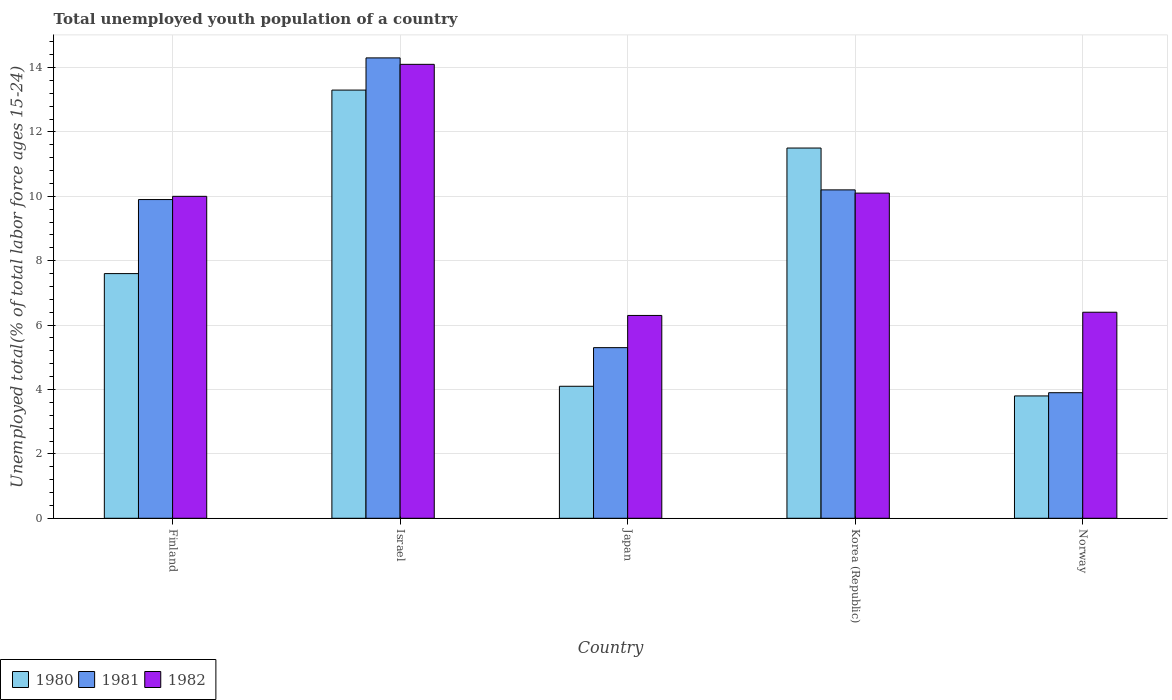How many different coloured bars are there?
Your answer should be compact. 3. How many groups of bars are there?
Keep it short and to the point. 5. How many bars are there on the 2nd tick from the left?
Your response must be concise. 3. How many bars are there on the 5th tick from the right?
Keep it short and to the point. 3. What is the label of the 2nd group of bars from the left?
Keep it short and to the point. Israel. What is the percentage of total unemployed youth population of a country in 1981 in Finland?
Ensure brevity in your answer.  9.9. Across all countries, what is the maximum percentage of total unemployed youth population of a country in 1981?
Ensure brevity in your answer.  14.3. Across all countries, what is the minimum percentage of total unemployed youth population of a country in 1980?
Offer a terse response. 3.8. What is the total percentage of total unemployed youth population of a country in 1982 in the graph?
Provide a short and direct response. 46.9. What is the difference between the percentage of total unemployed youth population of a country in 1980 in Israel and that in Korea (Republic)?
Your answer should be very brief. 1.8. What is the difference between the percentage of total unemployed youth population of a country in 1982 in Israel and the percentage of total unemployed youth population of a country in 1981 in Japan?
Offer a terse response. 8.8. What is the average percentage of total unemployed youth population of a country in 1982 per country?
Make the answer very short. 9.38. What is the difference between the percentage of total unemployed youth population of a country of/in 1980 and percentage of total unemployed youth population of a country of/in 1982 in Finland?
Offer a terse response. -2.4. In how many countries, is the percentage of total unemployed youth population of a country in 1981 greater than 1.6 %?
Your answer should be compact. 5. What is the ratio of the percentage of total unemployed youth population of a country in 1981 in Israel to that in Japan?
Give a very brief answer. 2.7. Is the percentage of total unemployed youth population of a country in 1981 in Israel less than that in Korea (Republic)?
Offer a terse response. No. Is the difference between the percentage of total unemployed youth population of a country in 1980 in Finland and Korea (Republic) greater than the difference between the percentage of total unemployed youth population of a country in 1982 in Finland and Korea (Republic)?
Make the answer very short. No. What is the difference between the highest and the second highest percentage of total unemployed youth population of a country in 1980?
Give a very brief answer. -1.8. What is the difference between the highest and the lowest percentage of total unemployed youth population of a country in 1981?
Offer a very short reply. 10.4. What does the 1st bar from the right in Japan represents?
Your answer should be compact. 1982. Is it the case that in every country, the sum of the percentage of total unemployed youth population of a country in 1980 and percentage of total unemployed youth population of a country in 1981 is greater than the percentage of total unemployed youth population of a country in 1982?
Give a very brief answer. Yes. How many bars are there?
Give a very brief answer. 15. Are all the bars in the graph horizontal?
Ensure brevity in your answer.  No. Are the values on the major ticks of Y-axis written in scientific E-notation?
Ensure brevity in your answer.  No. Does the graph contain grids?
Your response must be concise. Yes. Where does the legend appear in the graph?
Your answer should be compact. Bottom left. How are the legend labels stacked?
Your response must be concise. Horizontal. What is the title of the graph?
Make the answer very short. Total unemployed youth population of a country. What is the label or title of the Y-axis?
Ensure brevity in your answer.  Unemployed total(% of total labor force ages 15-24). What is the Unemployed total(% of total labor force ages 15-24) of 1980 in Finland?
Offer a terse response. 7.6. What is the Unemployed total(% of total labor force ages 15-24) in 1981 in Finland?
Your answer should be compact. 9.9. What is the Unemployed total(% of total labor force ages 15-24) in 1982 in Finland?
Provide a short and direct response. 10. What is the Unemployed total(% of total labor force ages 15-24) of 1980 in Israel?
Make the answer very short. 13.3. What is the Unemployed total(% of total labor force ages 15-24) of 1981 in Israel?
Ensure brevity in your answer.  14.3. What is the Unemployed total(% of total labor force ages 15-24) in 1982 in Israel?
Keep it short and to the point. 14.1. What is the Unemployed total(% of total labor force ages 15-24) of 1980 in Japan?
Keep it short and to the point. 4.1. What is the Unemployed total(% of total labor force ages 15-24) in 1981 in Japan?
Provide a short and direct response. 5.3. What is the Unemployed total(% of total labor force ages 15-24) of 1982 in Japan?
Ensure brevity in your answer.  6.3. What is the Unemployed total(% of total labor force ages 15-24) in 1980 in Korea (Republic)?
Ensure brevity in your answer.  11.5. What is the Unemployed total(% of total labor force ages 15-24) of 1981 in Korea (Republic)?
Offer a very short reply. 10.2. What is the Unemployed total(% of total labor force ages 15-24) of 1982 in Korea (Republic)?
Give a very brief answer. 10.1. What is the Unemployed total(% of total labor force ages 15-24) in 1980 in Norway?
Your answer should be compact. 3.8. What is the Unemployed total(% of total labor force ages 15-24) in 1981 in Norway?
Give a very brief answer. 3.9. What is the Unemployed total(% of total labor force ages 15-24) in 1982 in Norway?
Give a very brief answer. 6.4. Across all countries, what is the maximum Unemployed total(% of total labor force ages 15-24) of 1980?
Your answer should be compact. 13.3. Across all countries, what is the maximum Unemployed total(% of total labor force ages 15-24) in 1981?
Provide a short and direct response. 14.3. Across all countries, what is the maximum Unemployed total(% of total labor force ages 15-24) in 1982?
Provide a succinct answer. 14.1. Across all countries, what is the minimum Unemployed total(% of total labor force ages 15-24) of 1980?
Your answer should be very brief. 3.8. Across all countries, what is the minimum Unemployed total(% of total labor force ages 15-24) of 1981?
Keep it short and to the point. 3.9. Across all countries, what is the minimum Unemployed total(% of total labor force ages 15-24) of 1982?
Your answer should be compact. 6.3. What is the total Unemployed total(% of total labor force ages 15-24) of 1980 in the graph?
Give a very brief answer. 40.3. What is the total Unemployed total(% of total labor force ages 15-24) of 1981 in the graph?
Provide a short and direct response. 43.6. What is the total Unemployed total(% of total labor force ages 15-24) of 1982 in the graph?
Provide a succinct answer. 46.9. What is the difference between the Unemployed total(% of total labor force ages 15-24) in 1980 in Finland and that in Israel?
Ensure brevity in your answer.  -5.7. What is the difference between the Unemployed total(% of total labor force ages 15-24) in 1982 in Finland and that in Norway?
Your answer should be compact. 3.6. What is the difference between the Unemployed total(% of total labor force ages 15-24) in 1981 in Israel and that in Japan?
Your answer should be very brief. 9. What is the difference between the Unemployed total(% of total labor force ages 15-24) in 1982 in Israel and that in Japan?
Provide a short and direct response. 7.8. What is the difference between the Unemployed total(% of total labor force ages 15-24) in 1980 in Israel and that in Korea (Republic)?
Make the answer very short. 1.8. What is the difference between the Unemployed total(% of total labor force ages 15-24) in 1982 in Israel and that in Korea (Republic)?
Your response must be concise. 4. What is the difference between the Unemployed total(% of total labor force ages 15-24) in 1980 in Israel and that in Norway?
Ensure brevity in your answer.  9.5. What is the difference between the Unemployed total(% of total labor force ages 15-24) in 1981 in Israel and that in Norway?
Offer a terse response. 10.4. What is the difference between the Unemployed total(% of total labor force ages 15-24) in 1982 in Israel and that in Norway?
Your response must be concise. 7.7. What is the difference between the Unemployed total(% of total labor force ages 15-24) in 1980 in Japan and that in Korea (Republic)?
Provide a succinct answer. -7.4. What is the difference between the Unemployed total(% of total labor force ages 15-24) of 1981 in Japan and that in Korea (Republic)?
Your response must be concise. -4.9. What is the difference between the Unemployed total(% of total labor force ages 15-24) in 1982 in Japan and that in Korea (Republic)?
Your answer should be compact. -3.8. What is the difference between the Unemployed total(% of total labor force ages 15-24) in 1982 in Japan and that in Norway?
Make the answer very short. -0.1. What is the difference between the Unemployed total(% of total labor force ages 15-24) of 1980 in Korea (Republic) and that in Norway?
Your answer should be very brief. 7.7. What is the difference between the Unemployed total(% of total labor force ages 15-24) of 1980 in Finland and the Unemployed total(% of total labor force ages 15-24) of 1981 in Israel?
Your response must be concise. -6.7. What is the difference between the Unemployed total(% of total labor force ages 15-24) in 1981 in Finland and the Unemployed total(% of total labor force ages 15-24) in 1982 in Israel?
Offer a very short reply. -4.2. What is the difference between the Unemployed total(% of total labor force ages 15-24) in 1980 in Finland and the Unemployed total(% of total labor force ages 15-24) in 1982 in Japan?
Ensure brevity in your answer.  1.3. What is the difference between the Unemployed total(% of total labor force ages 15-24) in 1980 in Finland and the Unemployed total(% of total labor force ages 15-24) in 1981 in Korea (Republic)?
Give a very brief answer. -2.6. What is the difference between the Unemployed total(% of total labor force ages 15-24) in 1981 in Finland and the Unemployed total(% of total labor force ages 15-24) in 1982 in Norway?
Ensure brevity in your answer.  3.5. What is the difference between the Unemployed total(% of total labor force ages 15-24) in 1980 in Israel and the Unemployed total(% of total labor force ages 15-24) in 1981 in Japan?
Ensure brevity in your answer.  8. What is the difference between the Unemployed total(% of total labor force ages 15-24) of 1980 in Israel and the Unemployed total(% of total labor force ages 15-24) of 1982 in Japan?
Make the answer very short. 7. What is the difference between the Unemployed total(% of total labor force ages 15-24) of 1981 in Israel and the Unemployed total(% of total labor force ages 15-24) of 1982 in Japan?
Ensure brevity in your answer.  8. What is the difference between the Unemployed total(% of total labor force ages 15-24) of 1980 in Israel and the Unemployed total(% of total labor force ages 15-24) of 1981 in Korea (Republic)?
Offer a very short reply. 3.1. What is the difference between the Unemployed total(% of total labor force ages 15-24) of 1980 in Israel and the Unemployed total(% of total labor force ages 15-24) of 1982 in Korea (Republic)?
Offer a terse response. 3.2. What is the difference between the Unemployed total(% of total labor force ages 15-24) in 1981 in Israel and the Unemployed total(% of total labor force ages 15-24) in 1982 in Korea (Republic)?
Your response must be concise. 4.2. What is the difference between the Unemployed total(% of total labor force ages 15-24) in 1981 in Israel and the Unemployed total(% of total labor force ages 15-24) in 1982 in Norway?
Your response must be concise. 7.9. What is the difference between the Unemployed total(% of total labor force ages 15-24) in 1981 in Japan and the Unemployed total(% of total labor force ages 15-24) in 1982 in Korea (Republic)?
Your answer should be compact. -4.8. What is the difference between the Unemployed total(% of total labor force ages 15-24) in 1980 in Japan and the Unemployed total(% of total labor force ages 15-24) in 1982 in Norway?
Provide a succinct answer. -2.3. What is the difference between the Unemployed total(% of total labor force ages 15-24) in 1980 in Korea (Republic) and the Unemployed total(% of total labor force ages 15-24) in 1981 in Norway?
Provide a succinct answer. 7.6. What is the difference between the Unemployed total(% of total labor force ages 15-24) in 1980 in Korea (Republic) and the Unemployed total(% of total labor force ages 15-24) in 1982 in Norway?
Your answer should be very brief. 5.1. What is the average Unemployed total(% of total labor force ages 15-24) in 1980 per country?
Offer a terse response. 8.06. What is the average Unemployed total(% of total labor force ages 15-24) of 1981 per country?
Give a very brief answer. 8.72. What is the average Unemployed total(% of total labor force ages 15-24) of 1982 per country?
Keep it short and to the point. 9.38. What is the difference between the Unemployed total(% of total labor force ages 15-24) of 1980 and Unemployed total(% of total labor force ages 15-24) of 1982 in Finland?
Your answer should be very brief. -2.4. What is the difference between the Unemployed total(% of total labor force ages 15-24) of 1981 and Unemployed total(% of total labor force ages 15-24) of 1982 in Finland?
Ensure brevity in your answer.  -0.1. What is the difference between the Unemployed total(% of total labor force ages 15-24) in 1980 and Unemployed total(% of total labor force ages 15-24) in 1981 in Israel?
Give a very brief answer. -1. What is the difference between the Unemployed total(% of total labor force ages 15-24) of 1980 and Unemployed total(% of total labor force ages 15-24) of 1982 in Israel?
Make the answer very short. -0.8. What is the difference between the Unemployed total(% of total labor force ages 15-24) of 1981 and Unemployed total(% of total labor force ages 15-24) of 1982 in Israel?
Keep it short and to the point. 0.2. What is the difference between the Unemployed total(% of total labor force ages 15-24) in 1980 and Unemployed total(% of total labor force ages 15-24) in 1981 in Japan?
Offer a very short reply. -1.2. What is the difference between the Unemployed total(% of total labor force ages 15-24) of 1981 and Unemployed total(% of total labor force ages 15-24) of 1982 in Japan?
Give a very brief answer. -1. What is the difference between the Unemployed total(% of total labor force ages 15-24) of 1981 and Unemployed total(% of total labor force ages 15-24) of 1982 in Korea (Republic)?
Offer a very short reply. 0.1. What is the difference between the Unemployed total(% of total labor force ages 15-24) of 1981 and Unemployed total(% of total labor force ages 15-24) of 1982 in Norway?
Make the answer very short. -2.5. What is the ratio of the Unemployed total(% of total labor force ages 15-24) in 1980 in Finland to that in Israel?
Offer a very short reply. 0.57. What is the ratio of the Unemployed total(% of total labor force ages 15-24) in 1981 in Finland to that in Israel?
Ensure brevity in your answer.  0.69. What is the ratio of the Unemployed total(% of total labor force ages 15-24) of 1982 in Finland to that in Israel?
Offer a very short reply. 0.71. What is the ratio of the Unemployed total(% of total labor force ages 15-24) of 1980 in Finland to that in Japan?
Keep it short and to the point. 1.85. What is the ratio of the Unemployed total(% of total labor force ages 15-24) in 1981 in Finland to that in Japan?
Provide a succinct answer. 1.87. What is the ratio of the Unemployed total(% of total labor force ages 15-24) of 1982 in Finland to that in Japan?
Your response must be concise. 1.59. What is the ratio of the Unemployed total(% of total labor force ages 15-24) of 1980 in Finland to that in Korea (Republic)?
Provide a short and direct response. 0.66. What is the ratio of the Unemployed total(% of total labor force ages 15-24) in 1981 in Finland to that in Korea (Republic)?
Provide a succinct answer. 0.97. What is the ratio of the Unemployed total(% of total labor force ages 15-24) of 1982 in Finland to that in Korea (Republic)?
Provide a short and direct response. 0.99. What is the ratio of the Unemployed total(% of total labor force ages 15-24) of 1980 in Finland to that in Norway?
Ensure brevity in your answer.  2. What is the ratio of the Unemployed total(% of total labor force ages 15-24) in 1981 in Finland to that in Norway?
Keep it short and to the point. 2.54. What is the ratio of the Unemployed total(% of total labor force ages 15-24) in 1982 in Finland to that in Norway?
Provide a succinct answer. 1.56. What is the ratio of the Unemployed total(% of total labor force ages 15-24) of 1980 in Israel to that in Japan?
Offer a very short reply. 3.24. What is the ratio of the Unemployed total(% of total labor force ages 15-24) of 1981 in Israel to that in Japan?
Offer a very short reply. 2.7. What is the ratio of the Unemployed total(% of total labor force ages 15-24) of 1982 in Israel to that in Japan?
Keep it short and to the point. 2.24. What is the ratio of the Unemployed total(% of total labor force ages 15-24) of 1980 in Israel to that in Korea (Republic)?
Offer a terse response. 1.16. What is the ratio of the Unemployed total(% of total labor force ages 15-24) in 1981 in Israel to that in Korea (Republic)?
Keep it short and to the point. 1.4. What is the ratio of the Unemployed total(% of total labor force ages 15-24) of 1982 in Israel to that in Korea (Republic)?
Give a very brief answer. 1.4. What is the ratio of the Unemployed total(% of total labor force ages 15-24) of 1980 in Israel to that in Norway?
Provide a succinct answer. 3.5. What is the ratio of the Unemployed total(% of total labor force ages 15-24) of 1981 in Israel to that in Norway?
Your response must be concise. 3.67. What is the ratio of the Unemployed total(% of total labor force ages 15-24) of 1982 in Israel to that in Norway?
Provide a succinct answer. 2.2. What is the ratio of the Unemployed total(% of total labor force ages 15-24) in 1980 in Japan to that in Korea (Republic)?
Make the answer very short. 0.36. What is the ratio of the Unemployed total(% of total labor force ages 15-24) in 1981 in Japan to that in Korea (Republic)?
Your answer should be compact. 0.52. What is the ratio of the Unemployed total(% of total labor force ages 15-24) of 1982 in Japan to that in Korea (Republic)?
Offer a terse response. 0.62. What is the ratio of the Unemployed total(% of total labor force ages 15-24) in 1980 in Japan to that in Norway?
Keep it short and to the point. 1.08. What is the ratio of the Unemployed total(% of total labor force ages 15-24) of 1981 in Japan to that in Norway?
Offer a terse response. 1.36. What is the ratio of the Unemployed total(% of total labor force ages 15-24) of 1982 in Japan to that in Norway?
Ensure brevity in your answer.  0.98. What is the ratio of the Unemployed total(% of total labor force ages 15-24) in 1980 in Korea (Republic) to that in Norway?
Your answer should be very brief. 3.03. What is the ratio of the Unemployed total(% of total labor force ages 15-24) in 1981 in Korea (Republic) to that in Norway?
Offer a very short reply. 2.62. What is the ratio of the Unemployed total(% of total labor force ages 15-24) in 1982 in Korea (Republic) to that in Norway?
Provide a short and direct response. 1.58. What is the difference between the highest and the second highest Unemployed total(% of total labor force ages 15-24) in 1981?
Offer a very short reply. 4.1. What is the difference between the highest and the second highest Unemployed total(% of total labor force ages 15-24) in 1982?
Provide a short and direct response. 4. What is the difference between the highest and the lowest Unemployed total(% of total labor force ages 15-24) of 1981?
Provide a succinct answer. 10.4. What is the difference between the highest and the lowest Unemployed total(% of total labor force ages 15-24) in 1982?
Keep it short and to the point. 7.8. 